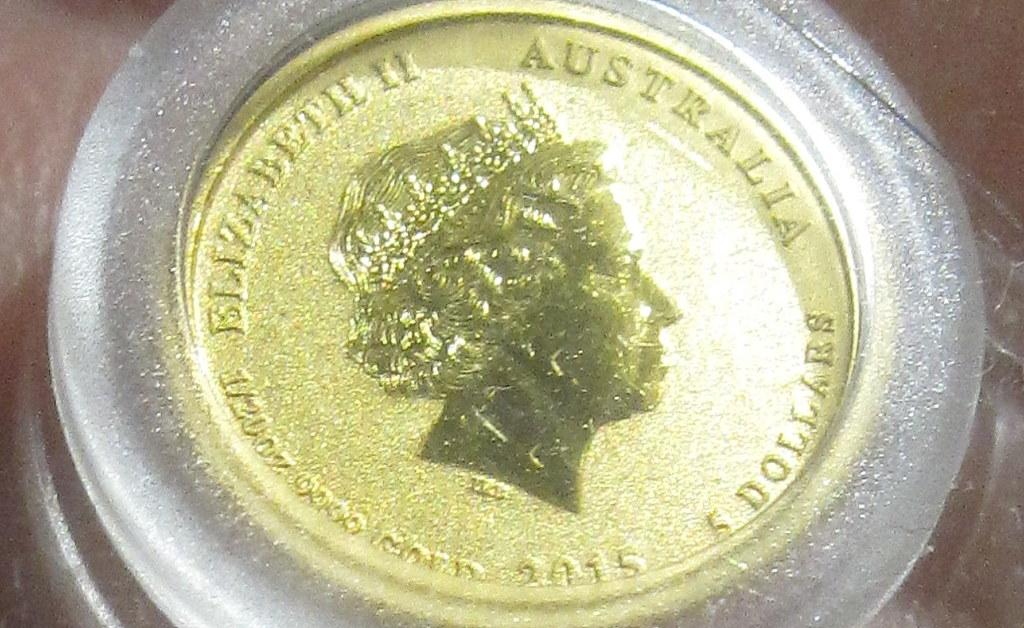<image>
Summarize the visual content of the image. The coin shown is from the country of Australia 